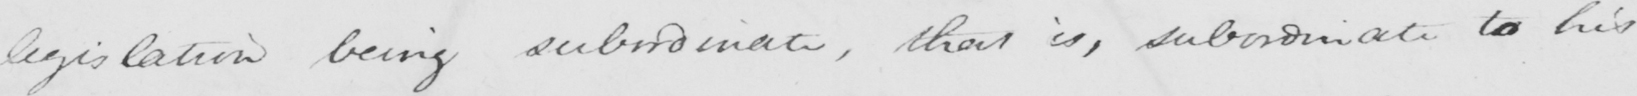What does this handwritten line say? legislation being subordinate , that is , subordinate to his 